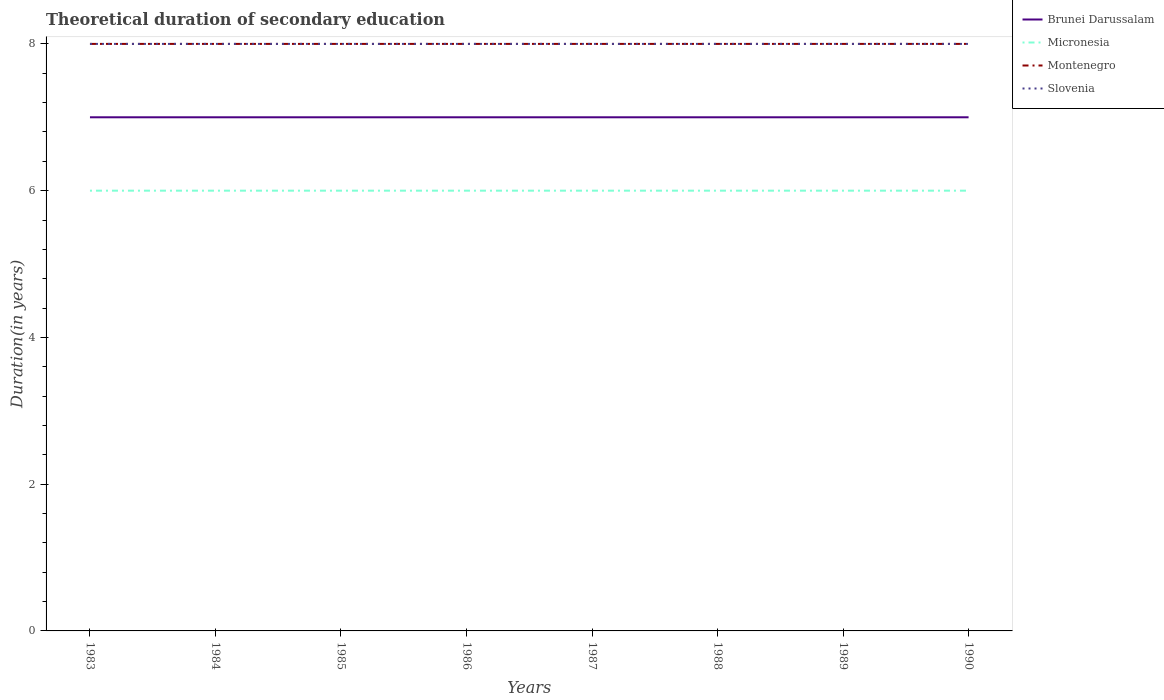Does the line corresponding to Montenegro intersect with the line corresponding to Slovenia?
Provide a succinct answer. Yes. Across all years, what is the maximum total theoretical duration of secondary education in Montenegro?
Your answer should be very brief. 8. What is the difference between the highest and the second highest total theoretical duration of secondary education in Slovenia?
Your response must be concise. 0. How many lines are there?
Provide a succinct answer. 4. Are the values on the major ticks of Y-axis written in scientific E-notation?
Provide a succinct answer. No. What is the title of the graph?
Keep it short and to the point. Theoretical duration of secondary education. What is the label or title of the X-axis?
Your answer should be very brief. Years. What is the label or title of the Y-axis?
Your response must be concise. Duration(in years). What is the Duration(in years) of Brunei Darussalam in 1983?
Your response must be concise. 7. What is the Duration(in years) of Micronesia in 1983?
Offer a very short reply. 6. What is the Duration(in years) of Montenegro in 1984?
Give a very brief answer. 8. What is the Duration(in years) in Slovenia in 1984?
Your answer should be compact. 8. What is the Duration(in years) in Montenegro in 1985?
Make the answer very short. 8. What is the Duration(in years) of Slovenia in 1985?
Make the answer very short. 8. What is the Duration(in years) of Brunei Darussalam in 1986?
Your answer should be compact. 7. What is the Duration(in years) in Micronesia in 1986?
Make the answer very short. 6. What is the Duration(in years) in Montenegro in 1986?
Provide a succinct answer. 8. What is the Duration(in years) in Montenegro in 1987?
Ensure brevity in your answer.  8. What is the Duration(in years) in Slovenia in 1987?
Provide a succinct answer. 8. What is the Duration(in years) of Micronesia in 1988?
Keep it short and to the point. 6. What is the Duration(in years) of Brunei Darussalam in 1989?
Give a very brief answer. 7. What is the Duration(in years) in Montenegro in 1989?
Your response must be concise. 8. What is the Duration(in years) of Slovenia in 1989?
Your answer should be very brief. 8. Across all years, what is the maximum Duration(in years) of Micronesia?
Provide a short and direct response. 6. Across all years, what is the maximum Duration(in years) in Slovenia?
Make the answer very short. 8. Across all years, what is the minimum Duration(in years) of Micronesia?
Provide a succinct answer. 6. What is the total Duration(in years) in Montenegro in the graph?
Give a very brief answer. 64. What is the difference between the Duration(in years) in Micronesia in 1983 and that in 1984?
Give a very brief answer. 0. What is the difference between the Duration(in years) of Montenegro in 1983 and that in 1985?
Offer a terse response. 0. What is the difference between the Duration(in years) in Brunei Darussalam in 1983 and that in 1986?
Offer a very short reply. 0. What is the difference between the Duration(in years) in Micronesia in 1983 and that in 1986?
Keep it short and to the point. 0. What is the difference between the Duration(in years) of Montenegro in 1983 and that in 1986?
Your answer should be compact. 0. What is the difference between the Duration(in years) of Micronesia in 1983 and that in 1987?
Your answer should be compact. 0. What is the difference between the Duration(in years) in Slovenia in 1983 and that in 1987?
Your answer should be compact. 0. What is the difference between the Duration(in years) of Brunei Darussalam in 1983 and that in 1988?
Make the answer very short. 0. What is the difference between the Duration(in years) in Montenegro in 1983 and that in 1988?
Offer a terse response. 0. What is the difference between the Duration(in years) of Brunei Darussalam in 1983 and that in 1989?
Provide a succinct answer. 0. What is the difference between the Duration(in years) in Micronesia in 1983 and that in 1989?
Ensure brevity in your answer.  0. What is the difference between the Duration(in years) in Slovenia in 1983 and that in 1989?
Ensure brevity in your answer.  0. What is the difference between the Duration(in years) of Brunei Darussalam in 1983 and that in 1990?
Ensure brevity in your answer.  0. What is the difference between the Duration(in years) in Montenegro in 1983 and that in 1990?
Offer a very short reply. 0. What is the difference between the Duration(in years) in Slovenia in 1983 and that in 1990?
Offer a terse response. 0. What is the difference between the Duration(in years) in Brunei Darussalam in 1984 and that in 1985?
Provide a short and direct response. 0. What is the difference between the Duration(in years) of Micronesia in 1984 and that in 1985?
Provide a short and direct response. 0. What is the difference between the Duration(in years) of Montenegro in 1984 and that in 1985?
Offer a terse response. 0. What is the difference between the Duration(in years) of Micronesia in 1984 and that in 1986?
Offer a very short reply. 0. What is the difference between the Duration(in years) of Slovenia in 1984 and that in 1986?
Offer a very short reply. 0. What is the difference between the Duration(in years) in Brunei Darussalam in 1984 and that in 1987?
Your answer should be very brief. 0. What is the difference between the Duration(in years) in Montenegro in 1984 and that in 1987?
Offer a terse response. 0. What is the difference between the Duration(in years) in Montenegro in 1984 and that in 1988?
Your answer should be very brief. 0. What is the difference between the Duration(in years) of Slovenia in 1984 and that in 1988?
Ensure brevity in your answer.  0. What is the difference between the Duration(in years) in Brunei Darussalam in 1984 and that in 1989?
Offer a terse response. 0. What is the difference between the Duration(in years) in Montenegro in 1984 and that in 1989?
Keep it short and to the point. 0. What is the difference between the Duration(in years) of Slovenia in 1984 and that in 1989?
Your response must be concise. 0. What is the difference between the Duration(in years) in Brunei Darussalam in 1984 and that in 1990?
Make the answer very short. 0. What is the difference between the Duration(in years) in Montenegro in 1984 and that in 1990?
Keep it short and to the point. 0. What is the difference between the Duration(in years) in Micronesia in 1985 and that in 1986?
Give a very brief answer. 0. What is the difference between the Duration(in years) in Montenegro in 1985 and that in 1986?
Your answer should be compact. 0. What is the difference between the Duration(in years) of Micronesia in 1985 and that in 1987?
Provide a succinct answer. 0. What is the difference between the Duration(in years) of Montenegro in 1985 and that in 1987?
Offer a very short reply. 0. What is the difference between the Duration(in years) of Slovenia in 1985 and that in 1987?
Offer a terse response. 0. What is the difference between the Duration(in years) of Montenegro in 1985 and that in 1988?
Keep it short and to the point. 0. What is the difference between the Duration(in years) in Slovenia in 1985 and that in 1988?
Make the answer very short. 0. What is the difference between the Duration(in years) of Micronesia in 1985 and that in 1989?
Provide a succinct answer. 0. What is the difference between the Duration(in years) in Brunei Darussalam in 1985 and that in 1990?
Your response must be concise. 0. What is the difference between the Duration(in years) in Micronesia in 1985 and that in 1990?
Keep it short and to the point. 0. What is the difference between the Duration(in years) in Montenegro in 1985 and that in 1990?
Your answer should be very brief. 0. What is the difference between the Duration(in years) in Slovenia in 1985 and that in 1990?
Provide a short and direct response. 0. What is the difference between the Duration(in years) of Brunei Darussalam in 1986 and that in 1987?
Your answer should be very brief. 0. What is the difference between the Duration(in years) in Micronesia in 1986 and that in 1987?
Your answer should be very brief. 0. What is the difference between the Duration(in years) of Brunei Darussalam in 1986 and that in 1988?
Keep it short and to the point. 0. What is the difference between the Duration(in years) of Montenegro in 1986 and that in 1988?
Your response must be concise. 0. What is the difference between the Duration(in years) of Brunei Darussalam in 1986 and that in 1989?
Make the answer very short. 0. What is the difference between the Duration(in years) in Micronesia in 1986 and that in 1989?
Your answer should be compact. 0. What is the difference between the Duration(in years) of Montenegro in 1986 and that in 1989?
Make the answer very short. 0. What is the difference between the Duration(in years) in Slovenia in 1986 and that in 1989?
Make the answer very short. 0. What is the difference between the Duration(in years) of Brunei Darussalam in 1986 and that in 1990?
Offer a very short reply. 0. What is the difference between the Duration(in years) of Montenegro in 1986 and that in 1990?
Ensure brevity in your answer.  0. What is the difference between the Duration(in years) in Micronesia in 1987 and that in 1988?
Make the answer very short. 0. What is the difference between the Duration(in years) in Micronesia in 1987 and that in 1990?
Ensure brevity in your answer.  0. What is the difference between the Duration(in years) in Micronesia in 1988 and that in 1989?
Provide a succinct answer. 0. What is the difference between the Duration(in years) of Montenegro in 1988 and that in 1989?
Ensure brevity in your answer.  0. What is the difference between the Duration(in years) of Slovenia in 1988 and that in 1989?
Provide a short and direct response. 0. What is the difference between the Duration(in years) in Brunei Darussalam in 1988 and that in 1990?
Your answer should be very brief. 0. What is the difference between the Duration(in years) of Micronesia in 1988 and that in 1990?
Offer a terse response. 0. What is the difference between the Duration(in years) of Montenegro in 1988 and that in 1990?
Provide a succinct answer. 0. What is the difference between the Duration(in years) of Slovenia in 1989 and that in 1990?
Your answer should be very brief. 0. What is the difference between the Duration(in years) of Brunei Darussalam in 1983 and the Duration(in years) of Micronesia in 1984?
Offer a very short reply. 1. What is the difference between the Duration(in years) of Micronesia in 1983 and the Duration(in years) of Montenegro in 1984?
Offer a very short reply. -2. What is the difference between the Duration(in years) in Micronesia in 1983 and the Duration(in years) in Slovenia in 1984?
Your answer should be compact. -2. What is the difference between the Duration(in years) in Brunei Darussalam in 1983 and the Duration(in years) in Montenegro in 1985?
Keep it short and to the point. -1. What is the difference between the Duration(in years) in Brunei Darussalam in 1983 and the Duration(in years) in Slovenia in 1985?
Your answer should be very brief. -1. What is the difference between the Duration(in years) of Micronesia in 1983 and the Duration(in years) of Slovenia in 1985?
Your response must be concise. -2. What is the difference between the Duration(in years) in Montenegro in 1983 and the Duration(in years) in Slovenia in 1985?
Your response must be concise. 0. What is the difference between the Duration(in years) of Micronesia in 1983 and the Duration(in years) of Montenegro in 1986?
Make the answer very short. -2. What is the difference between the Duration(in years) of Micronesia in 1983 and the Duration(in years) of Slovenia in 1986?
Your response must be concise. -2. What is the difference between the Duration(in years) of Brunei Darussalam in 1983 and the Duration(in years) of Micronesia in 1987?
Keep it short and to the point. 1. What is the difference between the Duration(in years) of Brunei Darussalam in 1983 and the Duration(in years) of Micronesia in 1988?
Provide a succinct answer. 1. What is the difference between the Duration(in years) of Brunei Darussalam in 1983 and the Duration(in years) of Slovenia in 1988?
Give a very brief answer. -1. What is the difference between the Duration(in years) in Micronesia in 1983 and the Duration(in years) in Slovenia in 1988?
Give a very brief answer. -2. What is the difference between the Duration(in years) in Brunei Darussalam in 1983 and the Duration(in years) in Micronesia in 1989?
Offer a very short reply. 1. What is the difference between the Duration(in years) of Micronesia in 1983 and the Duration(in years) of Slovenia in 1989?
Your answer should be compact. -2. What is the difference between the Duration(in years) in Brunei Darussalam in 1983 and the Duration(in years) in Slovenia in 1990?
Your answer should be compact. -1. What is the difference between the Duration(in years) of Micronesia in 1983 and the Duration(in years) of Slovenia in 1990?
Provide a short and direct response. -2. What is the difference between the Duration(in years) in Montenegro in 1983 and the Duration(in years) in Slovenia in 1990?
Ensure brevity in your answer.  0. What is the difference between the Duration(in years) in Brunei Darussalam in 1984 and the Duration(in years) in Micronesia in 1985?
Your answer should be compact. 1. What is the difference between the Duration(in years) in Brunei Darussalam in 1984 and the Duration(in years) in Montenegro in 1985?
Give a very brief answer. -1. What is the difference between the Duration(in years) in Montenegro in 1984 and the Duration(in years) in Slovenia in 1985?
Keep it short and to the point. 0. What is the difference between the Duration(in years) in Brunei Darussalam in 1984 and the Duration(in years) in Montenegro in 1986?
Give a very brief answer. -1. What is the difference between the Duration(in years) in Micronesia in 1984 and the Duration(in years) in Montenegro in 1986?
Offer a very short reply. -2. What is the difference between the Duration(in years) in Micronesia in 1984 and the Duration(in years) in Slovenia in 1986?
Make the answer very short. -2. What is the difference between the Duration(in years) of Montenegro in 1984 and the Duration(in years) of Slovenia in 1986?
Your answer should be compact. 0. What is the difference between the Duration(in years) in Brunei Darussalam in 1984 and the Duration(in years) in Micronesia in 1987?
Give a very brief answer. 1. What is the difference between the Duration(in years) in Brunei Darussalam in 1984 and the Duration(in years) in Slovenia in 1987?
Give a very brief answer. -1. What is the difference between the Duration(in years) in Micronesia in 1984 and the Duration(in years) in Montenegro in 1987?
Offer a terse response. -2. What is the difference between the Duration(in years) of Montenegro in 1984 and the Duration(in years) of Slovenia in 1987?
Your answer should be very brief. 0. What is the difference between the Duration(in years) in Brunei Darussalam in 1984 and the Duration(in years) in Slovenia in 1988?
Your response must be concise. -1. What is the difference between the Duration(in years) in Micronesia in 1984 and the Duration(in years) in Slovenia in 1988?
Make the answer very short. -2. What is the difference between the Duration(in years) of Montenegro in 1984 and the Duration(in years) of Slovenia in 1988?
Provide a succinct answer. 0. What is the difference between the Duration(in years) in Brunei Darussalam in 1984 and the Duration(in years) in Micronesia in 1989?
Your answer should be very brief. 1. What is the difference between the Duration(in years) in Brunei Darussalam in 1984 and the Duration(in years) in Montenegro in 1989?
Provide a short and direct response. -1. What is the difference between the Duration(in years) in Brunei Darussalam in 1984 and the Duration(in years) in Slovenia in 1989?
Your response must be concise. -1. What is the difference between the Duration(in years) of Brunei Darussalam in 1984 and the Duration(in years) of Montenegro in 1990?
Give a very brief answer. -1. What is the difference between the Duration(in years) in Brunei Darussalam in 1984 and the Duration(in years) in Slovenia in 1990?
Your response must be concise. -1. What is the difference between the Duration(in years) of Montenegro in 1984 and the Duration(in years) of Slovenia in 1990?
Make the answer very short. 0. What is the difference between the Duration(in years) of Brunei Darussalam in 1985 and the Duration(in years) of Montenegro in 1986?
Provide a succinct answer. -1. What is the difference between the Duration(in years) in Micronesia in 1985 and the Duration(in years) in Montenegro in 1986?
Ensure brevity in your answer.  -2. What is the difference between the Duration(in years) of Micronesia in 1985 and the Duration(in years) of Montenegro in 1987?
Give a very brief answer. -2. What is the difference between the Duration(in years) in Brunei Darussalam in 1985 and the Duration(in years) in Micronesia in 1988?
Give a very brief answer. 1. What is the difference between the Duration(in years) in Brunei Darussalam in 1985 and the Duration(in years) in Montenegro in 1988?
Ensure brevity in your answer.  -1. What is the difference between the Duration(in years) in Micronesia in 1985 and the Duration(in years) in Montenegro in 1988?
Keep it short and to the point. -2. What is the difference between the Duration(in years) in Brunei Darussalam in 1985 and the Duration(in years) in Montenegro in 1989?
Keep it short and to the point. -1. What is the difference between the Duration(in years) in Brunei Darussalam in 1985 and the Duration(in years) in Slovenia in 1989?
Offer a very short reply. -1. What is the difference between the Duration(in years) of Micronesia in 1985 and the Duration(in years) of Montenegro in 1989?
Make the answer very short. -2. What is the difference between the Duration(in years) of Micronesia in 1985 and the Duration(in years) of Slovenia in 1989?
Provide a short and direct response. -2. What is the difference between the Duration(in years) in Montenegro in 1985 and the Duration(in years) in Slovenia in 1990?
Your answer should be very brief. 0. What is the difference between the Duration(in years) in Brunei Darussalam in 1986 and the Duration(in years) in Montenegro in 1987?
Your response must be concise. -1. What is the difference between the Duration(in years) of Brunei Darussalam in 1986 and the Duration(in years) of Slovenia in 1987?
Your response must be concise. -1. What is the difference between the Duration(in years) of Micronesia in 1986 and the Duration(in years) of Montenegro in 1987?
Offer a terse response. -2. What is the difference between the Duration(in years) of Micronesia in 1986 and the Duration(in years) of Slovenia in 1987?
Ensure brevity in your answer.  -2. What is the difference between the Duration(in years) of Montenegro in 1986 and the Duration(in years) of Slovenia in 1987?
Keep it short and to the point. 0. What is the difference between the Duration(in years) of Brunei Darussalam in 1986 and the Duration(in years) of Micronesia in 1988?
Your answer should be very brief. 1. What is the difference between the Duration(in years) in Micronesia in 1986 and the Duration(in years) in Montenegro in 1988?
Provide a succinct answer. -2. What is the difference between the Duration(in years) of Brunei Darussalam in 1986 and the Duration(in years) of Micronesia in 1989?
Offer a terse response. 1. What is the difference between the Duration(in years) in Brunei Darussalam in 1986 and the Duration(in years) in Montenegro in 1989?
Give a very brief answer. -1. What is the difference between the Duration(in years) in Brunei Darussalam in 1986 and the Duration(in years) in Slovenia in 1989?
Your answer should be very brief. -1. What is the difference between the Duration(in years) of Montenegro in 1986 and the Duration(in years) of Slovenia in 1989?
Your answer should be compact. 0. What is the difference between the Duration(in years) of Brunei Darussalam in 1986 and the Duration(in years) of Micronesia in 1990?
Provide a succinct answer. 1. What is the difference between the Duration(in years) of Brunei Darussalam in 1986 and the Duration(in years) of Montenegro in 1990?
Provide a succinct answer. -1. What is the difference between the Duration(in years) in Brunei Darussalam in 1986 and the Duration(in years) in Slovenia in 1990?
Your answer should be very brief. -1. What is the difference between the Duration(in years) in Micronesia in 1986 and the Duration(in years) in Slovenia in 1990?
Your response must be concise. -2. What is the difference between the Duration(in years) in Brunei Darussalam in 1987 and the Duration(in years) in Micronesia in 1988?
Make the answer very short. 1. What is the difference between the Duration(in years) in Micronesia in 1987 and the Duration(in years) in Slovenia in 1988?
Make the answer very short. -2. What is the difference between the Duration(in years) of Montenegro in 1987 and the Duration(in years) of Slovenia in 1988?
Make the answer very short. 0. What is the difference between the Duration(in years) in Brunei Darussalam in 1987 and the Duration(in years) in Montenegro in 1989?
Offer a terse response. -1. What is the difference between the Duration(in years) in Brunei Darussalam in 1987 and the Duration(in years) in Slovenia in 1990?
Your answer should be very brief. -1. What is the difference between the Duration(in years) in Micronesia in 1987 and the Duration(in years) in Montenegro in 1990?
Ensure brevity in your answer.  -2. What is the difference between the Duration(in years) in Micronesia in 1987 and the Duration(in years) in Slovenia in 1990?
Give a very brief answer. -2. What is the difference between the Duration(in years) of Montenegro in 1987 and the Duration(in years) of Slovenia in 1990?
Give a very brief answer. 0. What is the difference between the Duration(in years) of Brunei Darussalam in 1988 and the Duration(in years) of Micronesia in 1989?
Your response must be concise. 1. What is the difference between the Duration(in years) in Brunei Darussalam in 1988 and the Duration(in years) in Montenegro in 1989?
Your response must be concise. -1. What is the difference between the Duration(in years) of Micronesia in 1988 and the Duration(in years) of Montenegro in 1989?
Make the answer very short. -2. What is the difference between the Duration(in years) in Micronesia in 1988 and the Duration(in years) in Slovenia in 1989?
Your answer should be compact. -2. What is the difference between the Duration(in years) of Montenegro in 1988 and the Duration(in years) of Slovenia in 1989?
Offer a very short reply. 0. What is the difference between the Duration(in years) in Brunei Darussalam in 1988 and the Duration(in years) in Micronesia in 1990?
Offer a terse response. 1. What is the difference between the Duration(in years) in Brunei Darussalam in 1988 and the Duration(in years) in Slovenia in 1990?
Your response must be concise. -1. What is the difference between the Duration(in years) in Brunei Darussalam in 1989 and the Duration(in years) in Montenegro in 1990?
Provide a succinct answer. -1. What is the difference between the Duration(in years) in Brunei Darussalam in 1989 and the Duration(in years) in Slovenia in 1990?
Provide a succinct answer. -1. What is the difference between the Duration(in years) of Micronesia in 1989 and the Duration(in years) of Montenegro in 1990?
Provide a succinct answer. -2. What is the difference between the Duration(in years) in Micronesia in 1989 and the Duration(in years) in Slovenia in 1990?
Your response must be concise. -2. What is the average Duration(in years) in Brunei Darussalam per year?
Your response must be concise. 7. What is the average Duration(in years) of Montenegro per year?
Your answer should be very brief. 8. In the year 1983, what is the difference between the Duration(in years) in Brunei Darussalam and Duration(in years) in Micronesia?
Your answer should be very brief. 1. In the year 1983, what is the difference between the Duration(in years) of Brunei Darussalam and Duration(in years) of Montenegro?
Your answer should be compact. -1. In the year 1983, what is the difference between the Duration(in years) in Micronesia and Duration(in years) in Slovenia?
Provide a succinct answer. -2. In the year 1983, what is the difference between the Duration(in years) in Montenegro and Duration(in years) in Slovenia?
Ensure brevity in your answer.  0. In the year 1984, what is the difference between the Duration(in years) in Brunei Darussalam and Duration(in years) in Micronesia?
Keep it short and to the point. 1. In the year 1984, what is the difference between the Duration(in years) of Brunei Darussalam and Duration(in years) of Montenegro?
Provide a short and direct response. -1. In the year 1984, what is the difference between the Duration(in years) of Micronesia and Duration(in years) of Slovenia?
Your answer should be very brief. -2. In the year 1984, what is the difference between the Duration(in years) in Montenegro and Duration(in years) in Slovenia?
Provide a succinct answer. 0. In the year 1985, what is the difference between the Duration(in years) in Brunei Darussalam and Duration(in years) in Slovenia?
Offer a terse response. -1. In the year 1985, what is the difference between the Duration(in years) in Micronesia and Duration(in years) in Slovenia?
Your response must be concise. -2. In the year 1986, what is the difference between the Duration(in years) in Brunei Darussalam and Duration(in years) in Micronesia?
Make the answer very short. 1. In the year 1986, what is the difference between the Duration(in years) of Brunei Darussalam and Duration(in years) of Montenegro?
Offer a terse response. -1. In the year 1986, what is the difference between the Duration(in years) of Brunei Darussalam and Duration(in years) of Slovenia?
Offer a very short reply. -1. In the year 1986, what is the difference between the Duration(in years) in Micronesia and Duration(in years) in Montenegro?
Your response must be concise. -2. In the year 1986, what is the difference between the Duration(in years) in Micronesia and Duration(in years) in Slovenia?
Your response must be concise. -2. In the year 1986, what is the difference between the Duration(in years) in Montenegro and Duration(in years) in Slovenia?
Make the answer very short. 0. In the year 1987, what is the difference between the Duration(in years) of Brunei Darussalam and Duration(in years) of Montenegro?
Offer a very short reply. -1. In the year 1987, what is the difference between the Duration(in years) of Brunei Darussalam and Duration(in years) of Slovenia?
Provide a succinct answer. -1. In the year 1988, what is the difference between the Duration(in years) of Brunei Darussalam and Duration(in years) of Micronesia?
Offer a terse response. 1. In the year 1988, what is the difference between the Duration(in years) of Brunei Darussalam and Duration(in years) of Montenegro?
Your answer should be very brief. -1. In the year 1988, what is the difference between the Duration(in years) of Brunei Darussalam and Duration(in years) of Slovenia?
Your answer should be very brief. -1. In the year 1988, what is the difference between the Duration(in years) of Micronesia and Duration(in years) of Montenegro?
Offer a very short reply. -2. In the year 1988, what is the difference between the Duration(in years) in Micronesia and Duration(in years) in Slovenia?
Offer a very short reply. -2. In the year 1988, what is the difference between the Duration(in years) in Montenegro and Duration(in years) in Slovenia?
Your response must be concise. 0. In the year 1989, what is the difference between the Duration(in years) in Brunei Darussalam and Duration(in years) in Montenegro?
Your answer should be very brief. -1. In the year 1989, what is the difference between the Duration(in years) of Micronesia and Duration(in years) of Montenegro?
Make the answer very short. -2. In the year 1989, what is the difference between the Duration(in years) of Micronesia and Duration(in years) of Slovenia?
Your response must be concise. -2. In the year 1990, what is the difference between the Duration(in years) of Brunei Darussalam and Duration(in years) of Micronesia?
Ensure brevity in your answer.  1. What is the ratio of the Duration(in years) of Brunei Darussalam in 1983 to that in 1984?
Keep it short and to the point. 1. What is the ratio of the Duration(in years) of Montenegro in 1983 to that in 1984?
Make the answer very short. 1. What is the ratio of the Duration(in years) of Micronesia in 1983 to that in 1985?
Provide a succinct answer. 1. What is the ratio of the Duration(in years) of Montenegro in 1983 to that in 1985?
Provide a short and direct response. 1. What is the ratio of the Duration(in years) in Brunei Darussalam in 1983 to that in 1986?
Keep it short and to the point. 1. What is the ratio of the Duration(in years) of Montenegro in 1983 to that in 1986?
Keep it short and to the point. 1. What is the ratio of the Duration(in years) in Montenegro in 1983 to that in 1987?
Keep it short and to the point. 1. What is the ratio of the Duration(in years) in Micronesia in 1983 to that in 1988?
Your answer should be very brief. 1. What is the ratio of the Duration(in years) of Montenegro in 1983 to that in 1988?
Offer a terse response. 1. What is the ratio of the Duration(in years) of Slovenia in 1983 to that in 1988?
Make the answer very short. 1. What is the ratio of the Duration(in years) of Brunei Darussalam in 1983 to that in 1989?
Your response must be concise. 1. What is the ratio of the Duration(in years) of Montenegro in 1983 to that in 1989?
Ensure brevity in your answer.  1. What is the ratio of the Duration(in years) in Montenegro in 1983 to that in 1990?
Make the answer very short. 1. What is the ratio of the Duration(in years) in Brunei Darussalam in 1984 to that in 1985?
Provide a short and direct response. 1. What is the ratio of the Duration(in years) of Montenegro in 1984 to that in 1985?
Provide a succinct answer. 1. What is the ratio of the Duration(in years) of Brunei Darussalam in 1984 to that in 1986?
Offer a very short reply. 1. What is the ratio of the Duration(in years) of Micronesia in 1984 to that in 1986?
Give a very brief answer. 1. What is the ratio of the Duration(in years) of Montenegro in 1984 to that in 1986?
Your answer should be compact. 1. What is the ratio of the Duration(in years) of Brunei Darussalam in 1984 to that in 1987?
Ensure brevity in your answer.  1. What is the ratio of the Duration(in years) of Micronesia in 1984 to that in 1987?
Provide a short and direct response. 1. What is the ratio of the Duration(in years) in Montenegro in 1984 to that in 1987?
Your answer should be very brief. 1. What is the ratio of the Duration(in years) in Slovenia in 1984 to that in 1987?
Your answer should be compact. 1. What is the ratio of the Duration(in years) of Slovenia in 1984 to that in 1988?
Your answer should be compact. 1. What is the ratio of the Duration(in years) in Micronesia in 1984 to that in 1989?
Provide a short and direct response. 1. What is the ratio of the Duration(in years) in Montenegro in 1984 to that in 1989?
Ensure brevity in your answer.  1. What is the ratio of the Duration(in years) of Slovenia in 1984 to that in 1989?
Keep it short and to the point. 1. What is the ratio of the Duration(in years) of Brunei Darussalam in 1984 to that in 1990?
Your answer should be very brief. 1. What is the ratio of the Duration(in years) in Slovenia in 1984 to that in 1990?
Your response must be concise. 1. What is the ratio of the Duration(in years) in Brunei Darussalam in 1985 to that in 1986?
Keep it short and to the point. 1. What is the ratio of the Duration(in years) of Micronesia in 1985 to that in 1986?
Ensure brevity in your answer.  1. What is the ratio of the Duration(in years) in Slovenia in 1985 to that in 1986?
Make the answer very short. 1. What is the ratio of the Duration(in years) in Micronesia in 1985 to that in 1987?
Offer a very short reply. 1. What is the ratio of the Duration(in years) in Micronesia in 1985 to that in 1988?
Your answer should be very brief. 1. What is the ratio of the Duration(in years) in Micronesia in 1985 to that in 1989?
Provide a succinct answer. 1. What is the ratio of the Duration(in years) of Montenegro in 1985 to that in 1989?
Provide a succinct answer. 1. What is the ratio of the Duration(in years) in Brunei Darussalam in 1985 to that in 1990?
Provide a short and direct response. 1. What is the ratio of the Duration(in years) of Slovenia in 1985 to that in 1990?
Your response must be concise. 1. What is the ratio of the Duration(in years) of Brunei Darussalam in 1986 to that in 1988?
Offer a terse response. 1. What is the ratio of the Duration(in years) in Micronesia in 1986 to that in 1988?
Give a very brief answer. 1. What is the ratio of the Duration(in years) of Montenegro in 1986 to that in 1988?
Offer a terse response. 1. What is the ratio of the Duration(in years) of Slovenia in 1986 to that in 1988?
Your response must be concise. 1. What is the ratio of the Duration(in years) in Montenegro in 1986 to that in 1989?
Keep it short and to the point. 1. What is the ratio of the Duration(in years) in Slovenia in 1986 to that in 1989?
Your response must be concise. 1. What is the ratio of the Duration(in years) in Brunei Darussalam in 1986 to that in 1990?
Your response must be concise. 1. What is the ratio of the Duration(in years) of Montenegro in 1986 to that in 1990?
Make the answer very short. 1. What is the ratio of the Duration(in years) of Slovenia in 1986 to that in 1990?
Offer a very short reply. 1. What is the ratio of the Duration(in years) in Montenegro in 1987 to that in 1988?
Give a very brief answer. 1. What is the ratio of the Duration(in years) in Slovenia in 1987 to that in 1988?
Your answer should be compact. 1. What is the ratio of the Duration(in years) in Brunei Darussalam in 1987 to that in 1989?
Offer a terse response. 1. What is the ratio of the Duration(in years) of Montenegro in 1987 to that in 1989?
Your answer should be compact. 1. What is the ratio of the Duration(in years) in Slovenia in 1987 to that in 1989?
Ensure brevity in your answer.  1. What is the ratio of the Duration(in years) in Brunei Darussalam in 1987 to that in 1990?
Give a very brief answer. 1. What is the ratio of the Duration(in years) of Micronesia in 1987 to that in 1990?
Your answer should be compact. 1. What is the ratio of the Duration(in years) in Montenegro in 1987 to that in 1990?
Offer a terse response. 1. What is the ratio of the Duration(in years) in Brunei Darussalam in 1988 to that in 1989?
Ensure brevity in your answer.  1. What is the ratio of the Duration(in years) of Micronesia in 1988 to that in 1990?
Offer a terse response. 1. What is the ratio of the Duration(in years) in Montenegro in 1988 to that in 1990?
Offer a very short reply. 1. What is the ratio of the Duration(in years) in Brunei Darussalam in 1989 to that in 1990?
Keep it short and to the point. 1. What is the ratio of the Duration(in years) in Montenegro in 1989 to that in 1990?
Provide a succinct answer. 1. What is the difference between the highest and the second highest Duration(in years) in Montenegro?
Give a very brief answer. 0. What is the difference between the highest and the second highest Duration(in years) in Slovenia?
Keep it short and to the point. 0. What is the difference between the highest and the lowest Duration(in years) in Brunei Darussalam?
Make the answer very short. 0. What is the difference between the highest and the lowest Duration(in years) in Montenegro?
Provide a short and direct response. 0. 